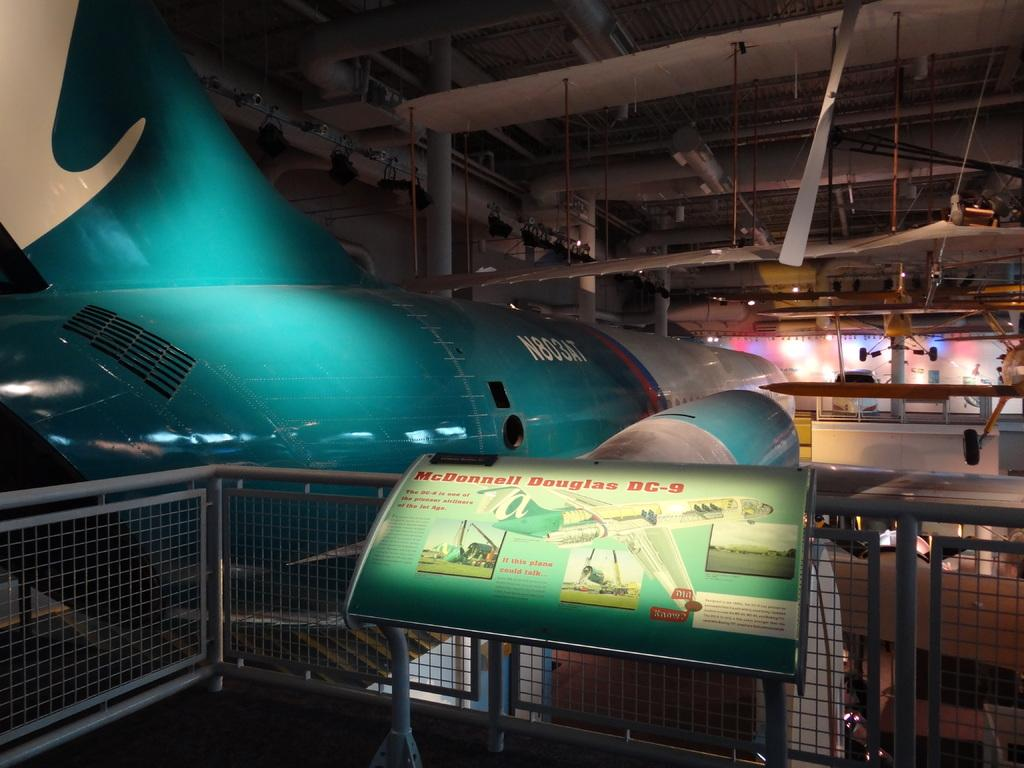<image>
Offer a succinct explanation of the picture presented. A plane, called the McDonnell Douglas DC-9, is on display in a museum. 